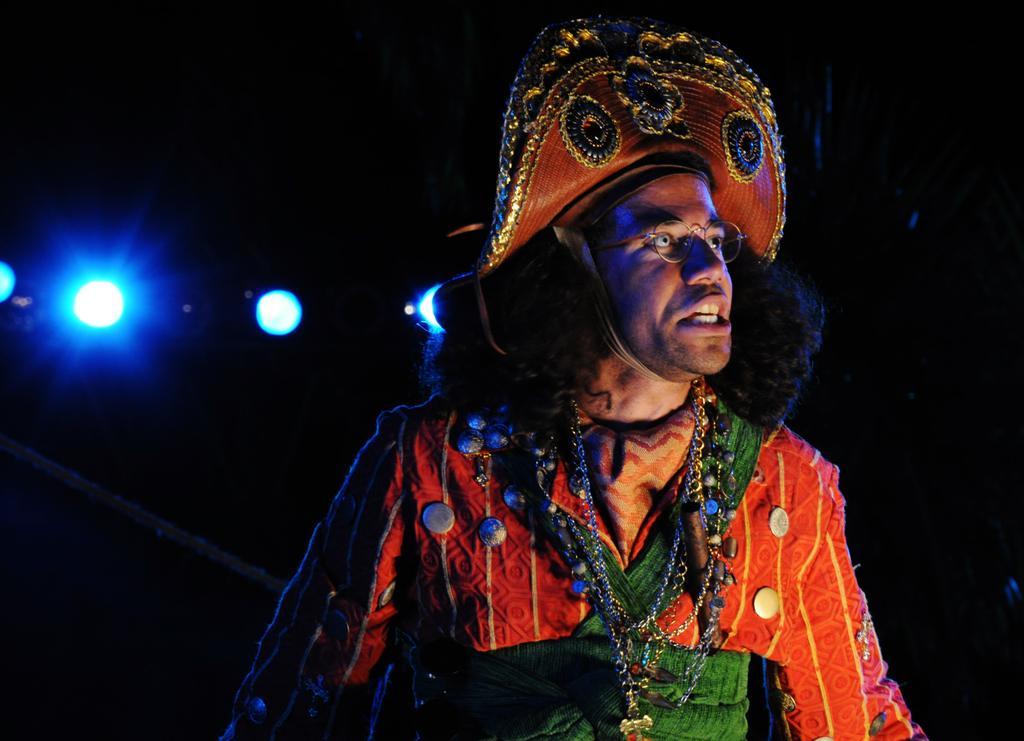Please provide a concise description of this image. In this picture we can see a man in the fancy dress and behind the man there is a dark background and lights. 